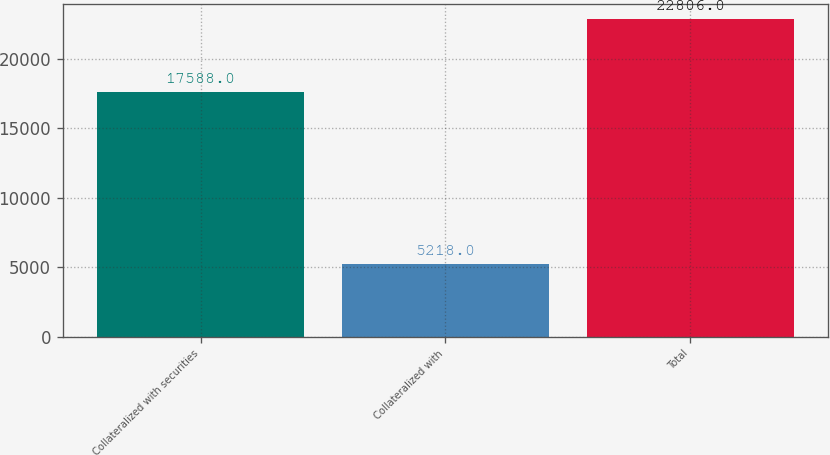Convert chart. <chart><loc_0><loc_0><loc_500><loc_500><bar_chart><fcel>Collateralized with securities<fcel>Collateralized with<fcel>Total<nl><fcel>17588<fcel>5218<fcel>22806<nl></chart> 